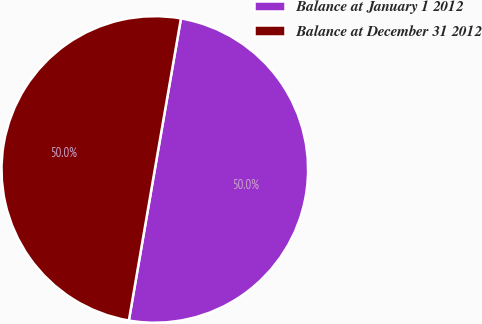<chart> <loc_0><loc_0><loc_500><loc_500><pie_chart><fcel>Balance at January 1 2012<fcel>Balance at December 31 2012<nl><fcel>49.98%<fcel>50.02%<nl></chart> 